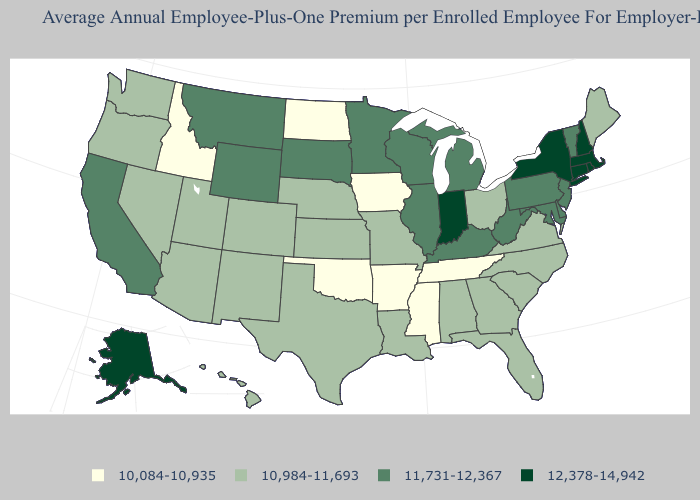Name the states that have a value in the range 10,084-10,935?
Concise answer only. Arkansas, Idaho, Iowa, Mississippi, North Dakota, Oklahoma, Tennessee. Does Georgia have the highest value in the USA?
Quick response, please. No. What is the highest value in the USA?
Keep it brief. 12,378-14,942. Does the first symbol in the legend represent the smallest category?
Short answer required. Yes. What is the value of Virginia?
Write a very short answer. 10,984-11,693. Name the states that have a value in the range 12,378-14,942?
Write a very short answer. Alaska, Connecticut, Indiana, Massachusetts, New Hampshire, New York, Rhode Island. Among the states that border New Jersey , does Delaware have the highest value?
Be succinct. No. Which states have the lowest value in the USA?
Keep it brief. Arkansas, Idaho, Iowa, Mississippi, North Dakota, Oklahoma, Tennessee. What is the value of Ohio?
Answer briefly. 10,984-11,693. Does West Virginia have the lowest value in the USA?
Be succinct. No. Name the states that have a value in the range 10,084-10,935?
Be succinct. Arkansas, Idaho, Iowa, Mississippi, North Dakota, Oklahoma, Tennessee. Does Maryland have the same value as Massachusetts?
Give a very brief answer. No. Name the states that have a value in the range 11,731-12,367?
Write a very short answer. California, Delaware, Illinois, Kentucky, Maryland, Michigan, Minnesota, Montana, New Jersey, Pennsylvania, South Dakota, Vermont, West Virginia, Wisconsin, Wyoming. What is the value of New Mexico?
Quick response, please. 10,984-11,693. Name the states that have a value in the range 11,731-12,367?
Give a very brief answer. California, Delaware, Illinois, Kentucky, Maryland, Michigan, Minnesota, Montana, New Jersey, Pennsylvania, South Dakota, Vermont, West Virginia, Wisconsin, Wyoming. 